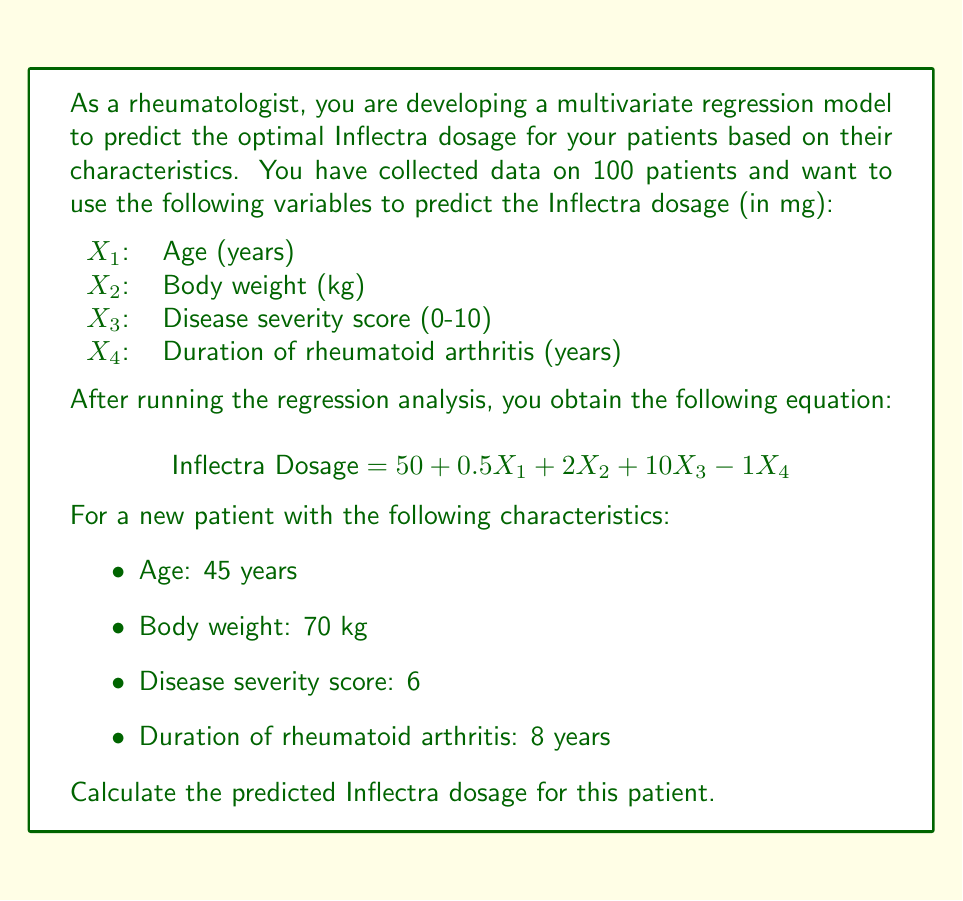Solve this math problem. To calculate the predicted Inflectra dosage for the new patient, we need to substitute the given values into the multivariate regression equation:

$$ \text{Inflectra Dosage} = 50 + 0.5X_1 + 2X_2 + 10X_3 - 1X_4 $$

Let's substitute the values:

$X_1$ (Age) = 45 years
$X_2$ (Body weight) = 70 kg
$X_3$ (Disease severity score) = 6
$X_4$ (Duration of rheumatoid arthritis) = 8 years

Now, let's calculate step by step:

1. Constant term: 50
2. Age term: $0.5 \times 45 = 22.5$
3. Body weight term: $2 \times 70 = 140$
4. Disease severity score term: $10 \times 6 = 60$
5. Duration of rheumatoid arthritis term: $-1 \times 8 = -8$

Sum all the terms:

$$ \text{Inflectra Dosage} = 50 + 22.5 + 140 + 60 - 8 $$

$$ \text{Inflectra Dosage} = 264.5 \text{ mg} $$

Therefore, the predicted Inflectra dosage for this patient is 264.5 mg.
Answer: The predicted Inflectra dosage for the patient is 264.5 mg. 